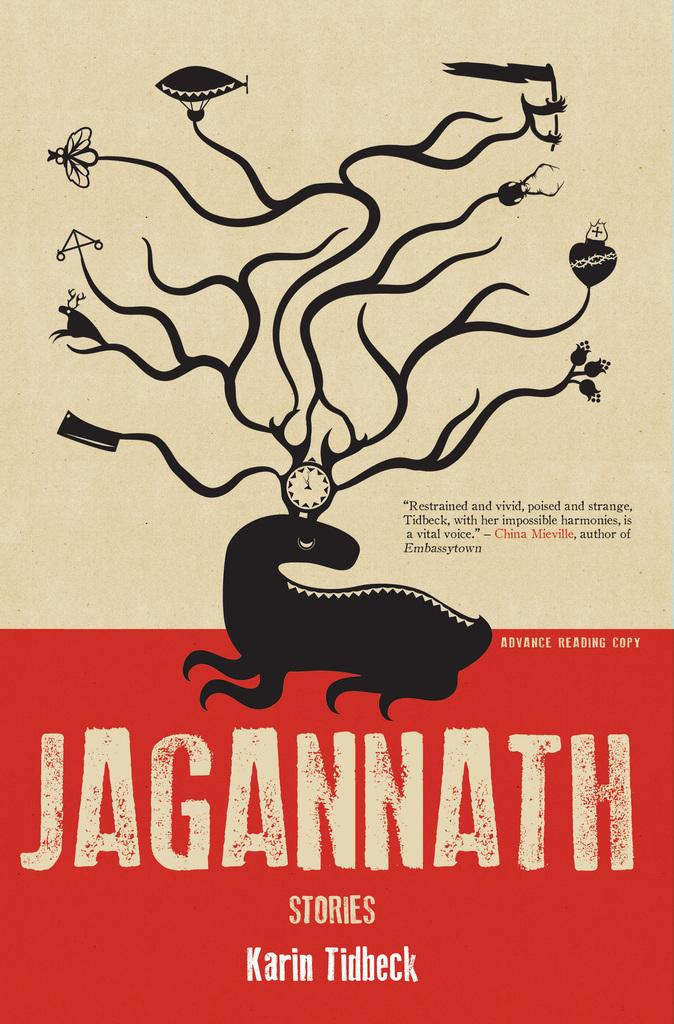What is the main subject in the center of the image? There is a poster in the center of the image. What can be read on the poster? The poster has the word "Jagannath" written on it. What type of hat is the person wearing in the image? There is no person wearing a hat in the image; it only features a poster with the word "Jagannath" written on it. 